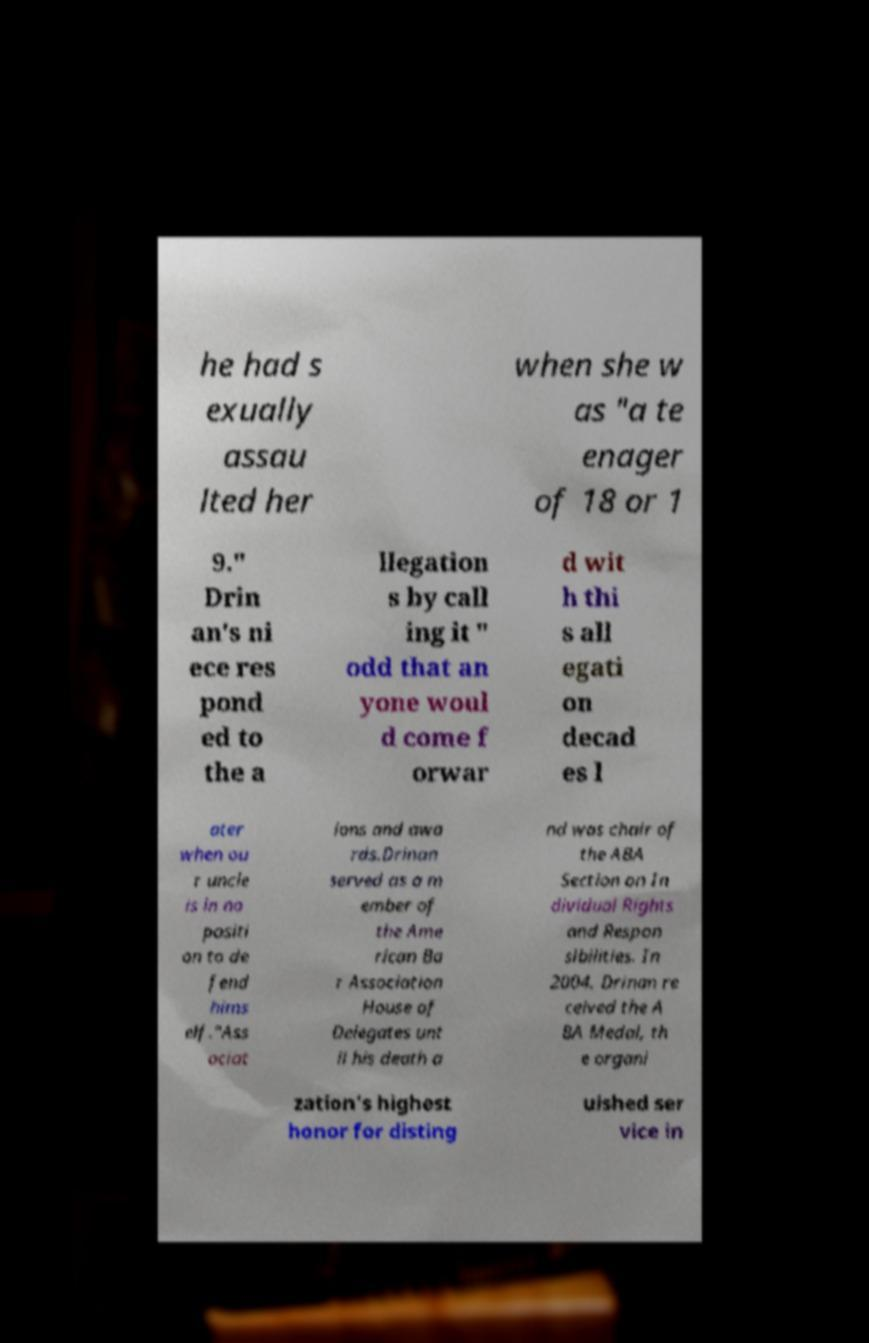Can you accurately transcribe the text from the provided image for me? he had s exually assau lted her when she w as "a te enager of 18 or 1 9." Drin an's ni ece res pond ed to the a llegation s by call ing it " odd that an yone woul d come f orwar d wit h thi s all egati on decad es l ater when ou r uncle is in no positi on to de fend hims elf."Ass ociat ions and awa rds.Drinan served as a m ember of the Ame rican Ba r Association House of Delegates unt il his death a nd was chair of the ABA Section on In dividual Rights and Respon sibilities. In 2004, Drinan re ceived the A BA Medal, th e organi zation's highest honor for disting uished ser vice in 